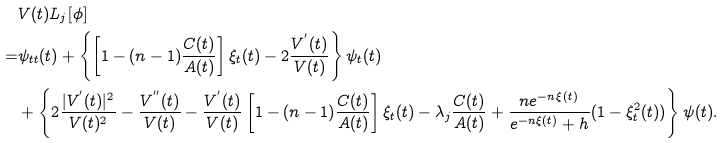Convert formula to latex. <formula><loc_0><loc_0><loc_500><loc_500>& V ( t ) { L } _ { j } [ \phi ] \\ = & \psi _ { t t } ( t ) + \left \{ \left [ 1 - ( n - 1 ) \frac { C ( t ) } { A ( t ) } \right ] \xi _ { t } ( t ) - 2 \frac { V ^ { ^ { \prime } } ( t ) } { V ( t ) } \right \} \psi _ { t } ( t ) \\ & + \left \{ 2 \frac { | V ^ { ^ { \prime } } ( t ) | ^ { 2 } } { V ( t ) ^ { 2 } } - \frac { V ^ { ^ { \prime \prime } } ( t ) } { V ( t ) } - \frac { V ^ { ^ { \prime } } ( t ) } { V ( t ) } \left [ 1 - ( n - 1 ) \frac { C ( t ) } { A ( t ) } \right ] \xi _ { t } ( t ) - \lambda _ { j } \frac { C ( t ) } { A ( t ) } + \frac { n e ^ { - n \xi ( t ) } } { e ^ { - n \xi ( t ) } + h } ( 1 - \xi _ { t } ^ { 2 } ( t ) ) \right \} \psi ( t ) .</formula> 